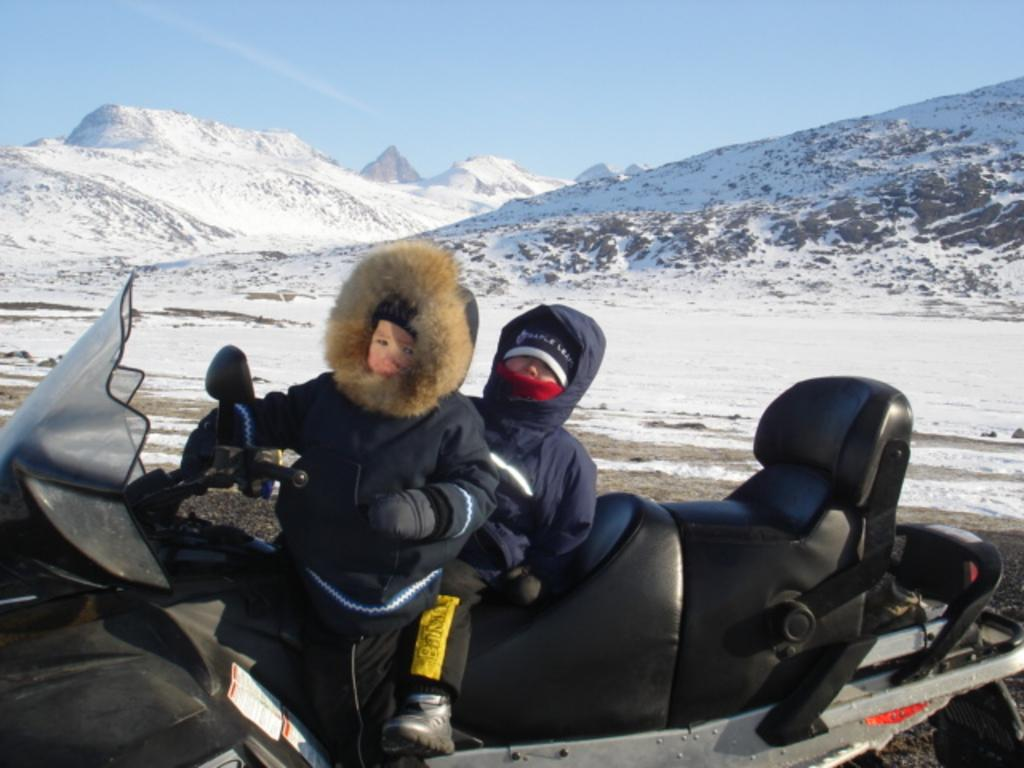How many people are on the vehicle in the image? There are two persons on the vehicle. What is the terrain like in the image? The vehicle is in an area with snow. What can be seen in the background of the image? There is a mountain and the sky visible in the background of the image. What type of beef is being served on the mountain in the image? There is no beef present in the image, and the mountain is in the background, not the foreground. 